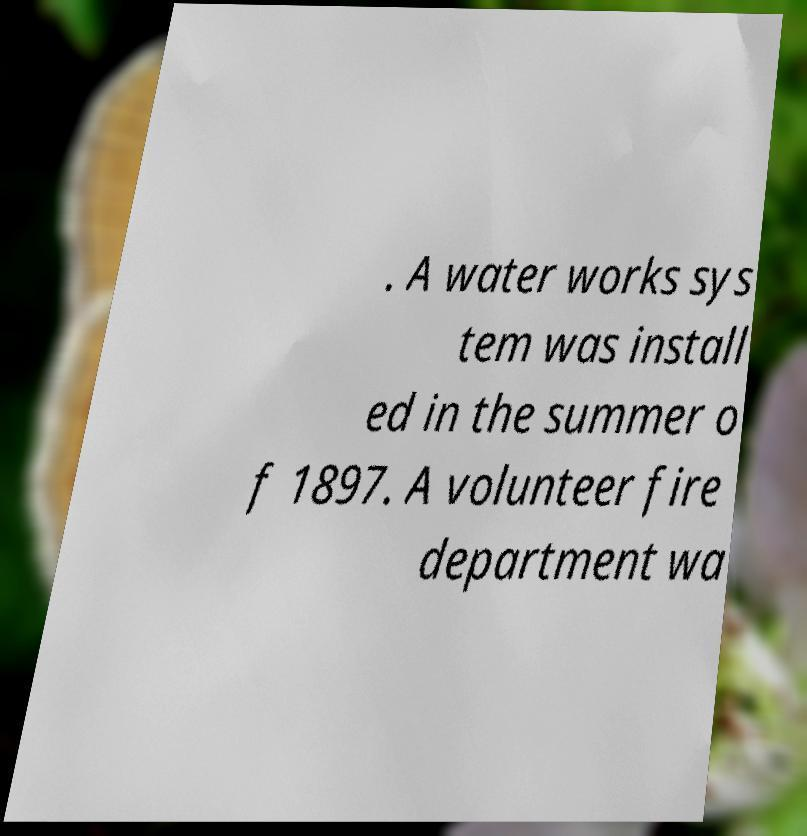There's text embedded in this image that I need extracted. Can you transcribe it verbatim? . A water works sys tem was install ed in the summer o f 1897. A volunteer fire department wa 